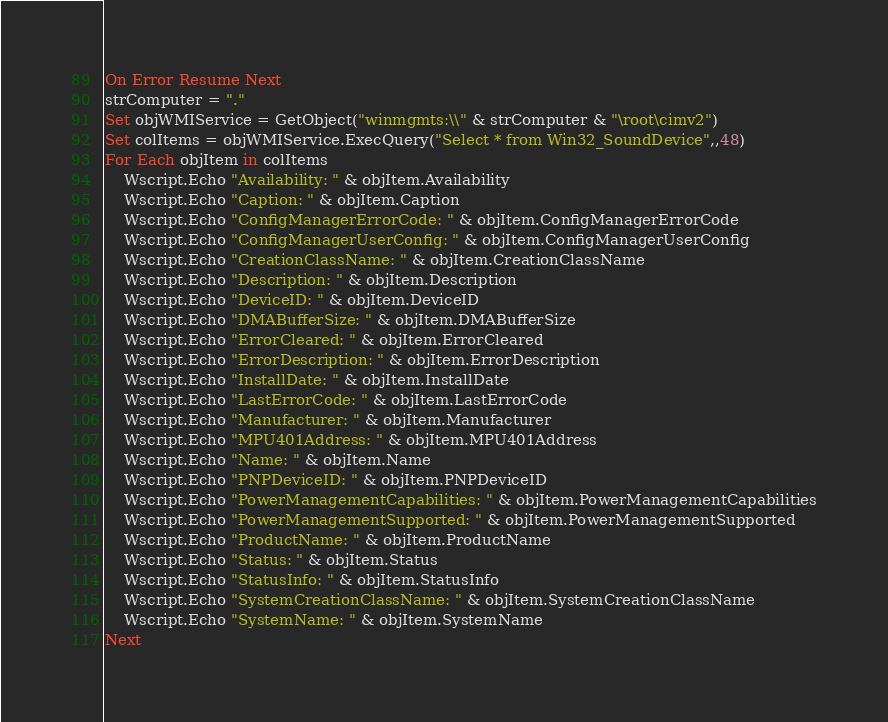<code> <loc_0><loc_0><loc_500><loc_500><_VisualBasic_>On Error Resume Next
strComputer = "."
Set objWMIService = GetObject("winmgmts:\\" & strComputer & "\root\cimv2")
Set colItems = objWMIService.ExecQuery("Select * from Win32_SoundDevice",,48)
For Each objItem in colItems
    Wscript.Echo "Availability: " & objItem.Availability
    Wscript.Echo "Caption: " & objItem.Caption
    Wscript.Echo "ConfigManagerErrorCode: " & objItem.ConfigManagerErrorCode
    Wscript.Echo "ConfigManagerUserConfig: " & objItem.ConfigManagerUserConfig
    Wscript.Echo "CreationClassName: " & objItem.CreationClassName
    Wscript.Echo "Description: " & objItem.Description
    Wscript.Echo "DeviceID: " & objItem.DeviceID
    Wscript.Echo "DMABufferSize: " & objItem.DMABufferSize
    Wscript.Echo "ErrorCleared: " & objItem.ErrorCleared
    Wscript.Echo "ErrorDescription: " & objItem.ErrorDescription
    Wscript.Echo "InstallDate: " & objItem.InstallDate
    Wscript.Echo "LastErrorCode: " & objItem.LastErrorCode
    Wscript.Echo "Manufacturer: " & objItem.Manufacturer
    Wscript.Echo "MPU401Address: " & objItem.MPU401Address
    Wscript.Echo "Name: " & objItem.Name
    Wscript.Echo "PNPDeviceID: " & objItem.PNPDeviceID
    Wscript.Echo "PowerManagementCapabilities: " & objItem.PowerManagementCapabilities
    Wscript.Echo "PowerManagementSupported: " & objItem.PowerManagementSupported
    Wscript.Echo "ProductName: " & objItem.ProductName
    Wscript.Echo "Status: " & objItem.Status
    Wscript.Echo "StatusInfo: " & objItem.StatusInfo
    Wscript.Echo "SystemCreationClassName: " & objItem.SystemCreationClassName
    Wscript.Echo "SystemName: " & objItem.SystemName
Next

</code> 